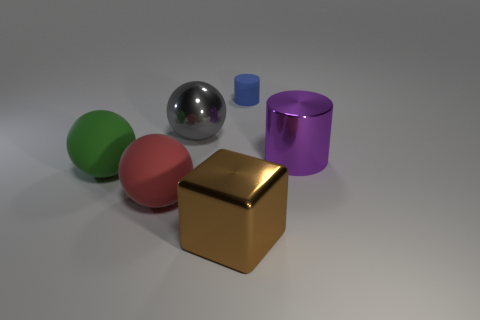Are there any other things that have the same size as the rubber cylinder?
Give a very brief answer. No. Do the large matte sphere that is in front of the green rubber ball and the metallic block have the same color?
Offer a terse response. No. How many balls are the same size as the gray object?
Make the answer very short. 2. What shape is the purple object that is made of the same material as the large brown thing?
Your response must be concise. Cylinder. Are there any tiny matte cylinders of the same color as the block?
Offer a terse response. No. What is the blue thing made of?
Offer a very short reply. Rubber. How many objects are either large red matte objects or green rubber spheres?
Give a very brief answer. 2. There is a rubber object behind the green rubber ball; what is its size?
Your answer should be compact. Small. What number of other objects are there of the same material as the tiny blue thing?
Keep it short and to the point. 2. There is a metal object left of the large brown metallic object; is there a tiny matte cylinder to the left of it?
Your response must be concise. No. 